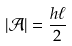<formula> <loc_0><loc_0><loc_500><loc_500>| \mathcal { A } | = \frac { h \ell } { 2 }</formula> 